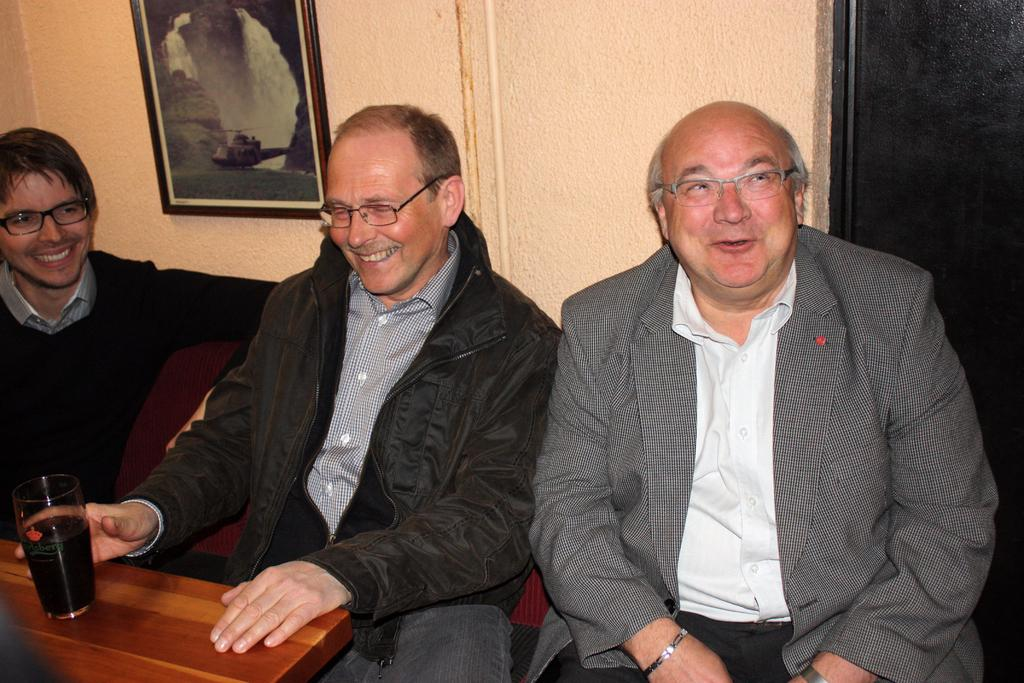How many people are present in the image? There are three people in the image. What are the people doing in the image? The people are sitting in front of a table. Can you describe the actions of one of the people? One person is holding a glass. What can be seen in the background of the image? There is a frame on the wall in the background. What type of thought can be seen in the image? There are no thoughts visible in the image; it is a photograph of people sitting at a table. What kind of noise is being made by the swing in the image? There is no swing present in the image, so it is not possible to determine what kind of noise might be made. 